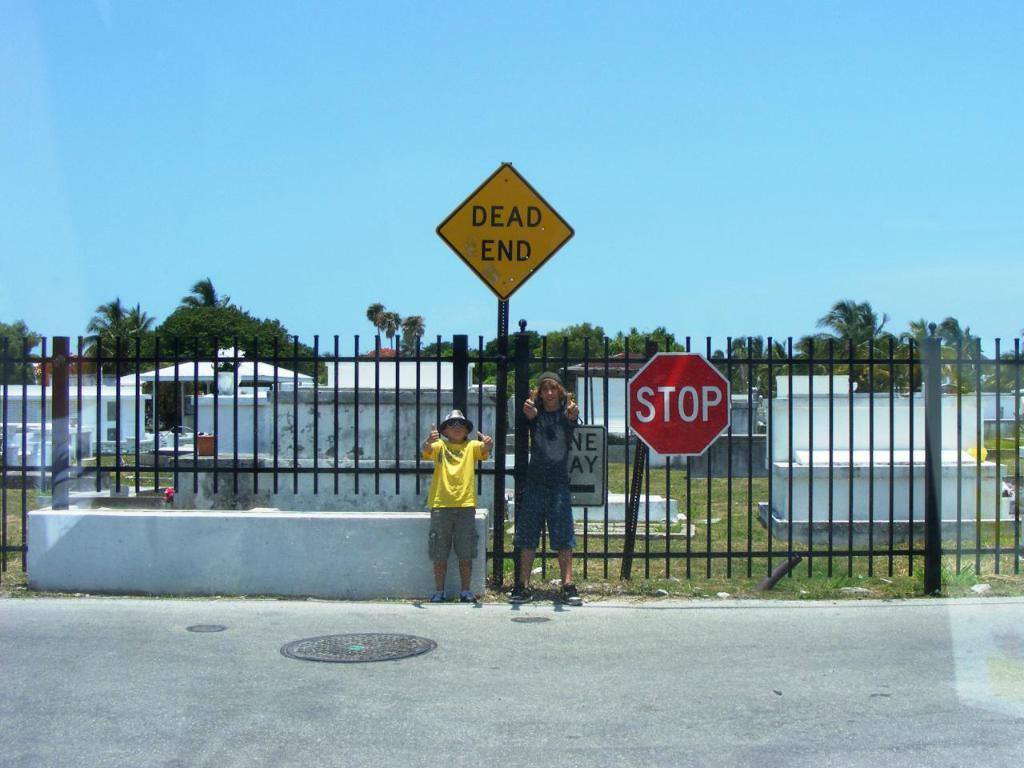What does the red sign say?
Keep it short and to the point. Stop. What does the sign say to the right of the boy?
Your answer should be compact. Stop. 